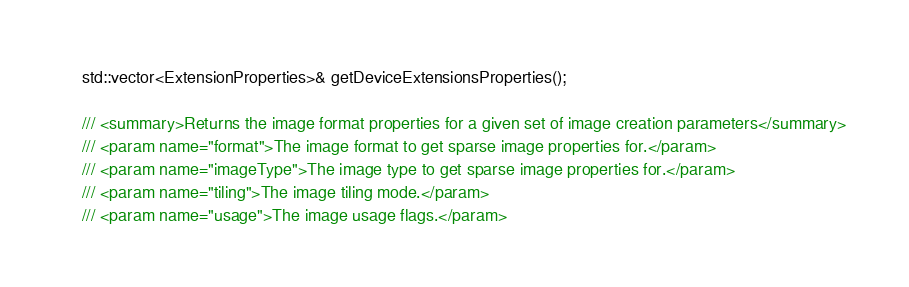<code> <loc_0><loc_0><loc_500><loc_500><_C_>	std::vector<ExtensionProperties>& getDeviceExtensionsProperties();

	/// <summary>Returns the image format properties for a given set of image creation parameters</summary>
	/// <param name="format">The image format to get sparse image properties for.</param>
	/// <param name="imageType">The image type to get sparse image properties for.</param>
	/// <param name="tiling">The image tiling mode.</param>
	/// <param name="usage">The image usage flags.</param></code> 